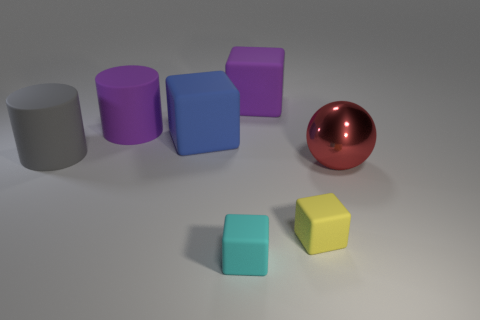Add 1 purple matte cylinders. How many objects exist? 8 Subtract all cylinders. How many objects are left? 5 Add 2 big rubber cubes. How many big rubber cubes are left? 4 Add 6 big shiny spheres. How many big shiny spheres exist? 7 Subtract 0 red cylinders. How many objects are left? 7 Subtract all purple cubes. Subtract all purple cylinders. How many objects are left? 5 